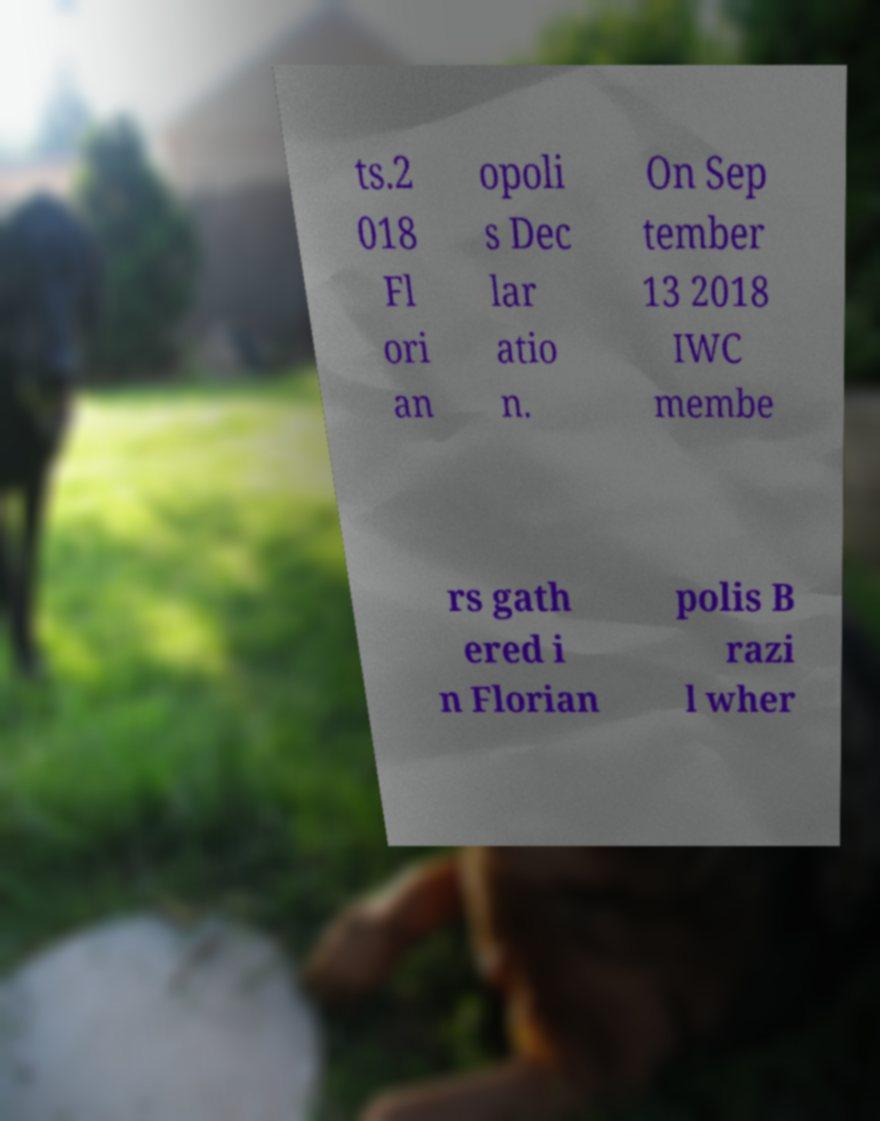Can you accurately transcribe the text from the provided image for me? ts.2 018 Fl ori an opoli s Dec lar atio n. On Sep tember 13 2018 IWC membe rs gath ered i n Florian polis B razi l wher 